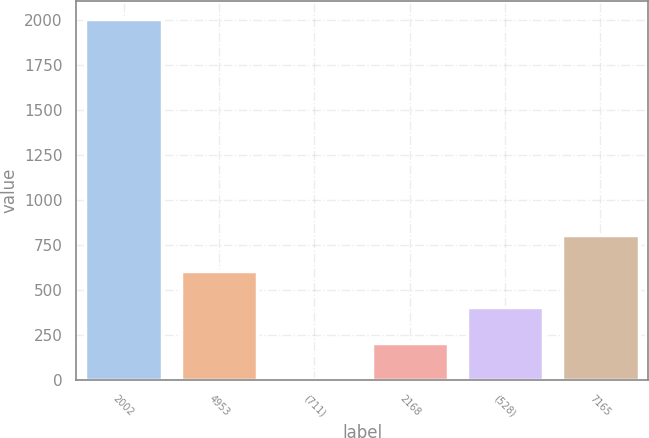<chart> <loc_0><loc_0><loc_500><loc_500><bar_chart><fcel>2002<fcel>4953<fcel>(711)<fcel>2168<fcel>(528)<fcel>7165<nl><fcel>2002<fcel>602.28<fcel>2.4<fcel>202.36<fcel>402.32<fcel>802.24<nl></chart> 